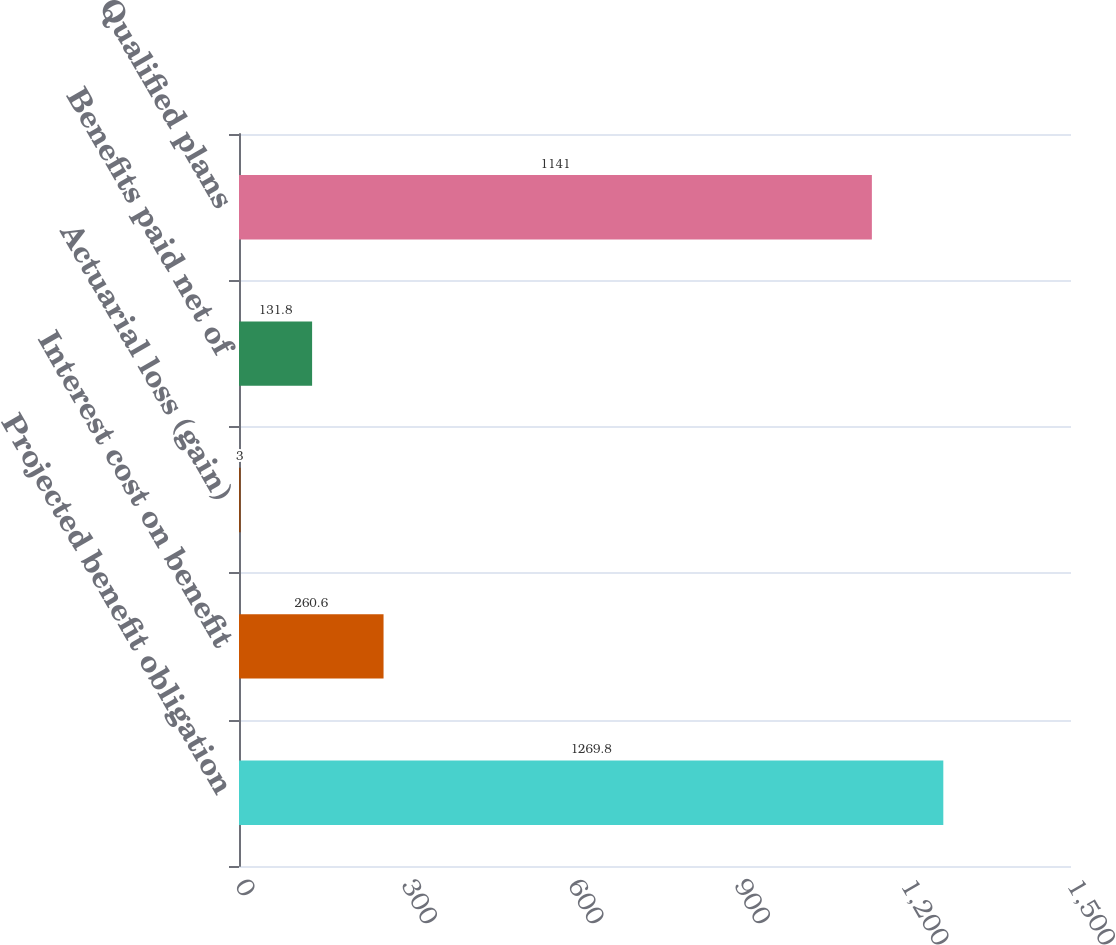<chart> <loc_0><loc_0><loc_500><loc_500><bar_chart><fcel>Projected benefit obligation<fcel>Interest cost on benefit<fcel>Actuarial loss (gain)<fcel>Benefits paid net of<fcel>Qualified plans<nl><fcel>1269.8<fcel>260.6<fcel>3<fcel>131.8<fcel>1141<nl></chart> 